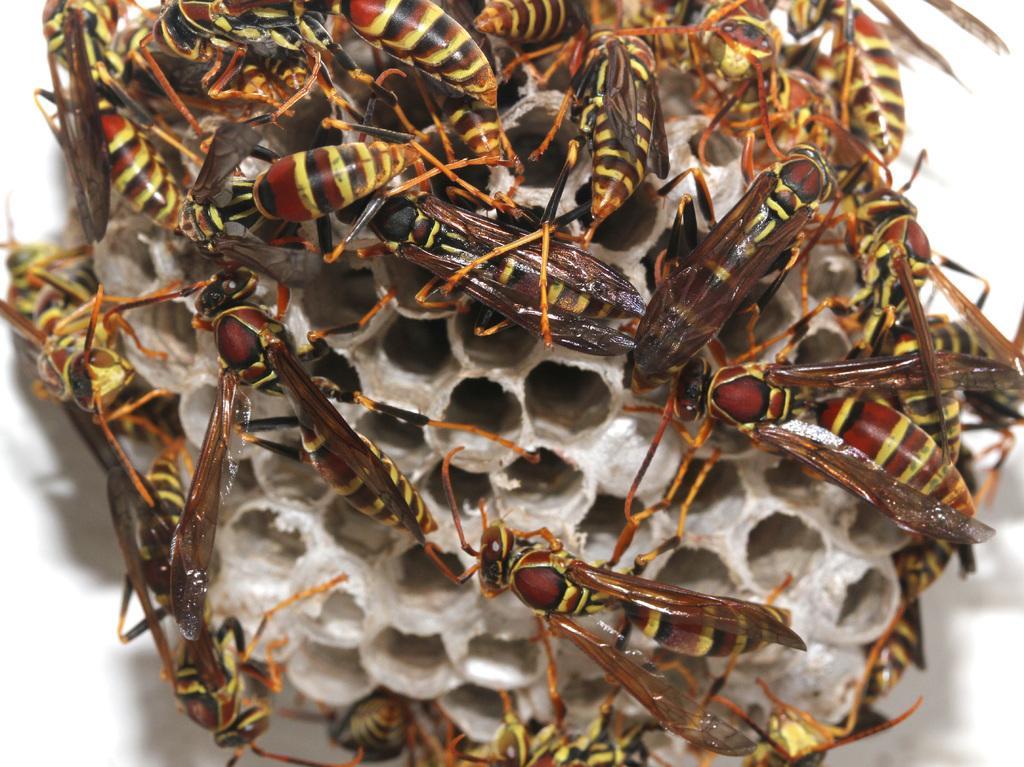How would you summarize this image in a sentence or two? In the center of this picture we can see a honeycomb and we can see many number of honey bees on the honeycomb. 